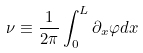Convert formula to latex. <formula><loc_0><loc_0><loc_500><loc_500>\nu \equiv \frac { 1 } { 2 \pi } \int _ { 0 } ^ { L } \partial _ { x } \varphi d x</formula> 